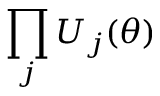<formula> <loc_0><loc_0><loc_500><loc_500>\prod _ { j } U _ { j } ( \theta )</formula> 